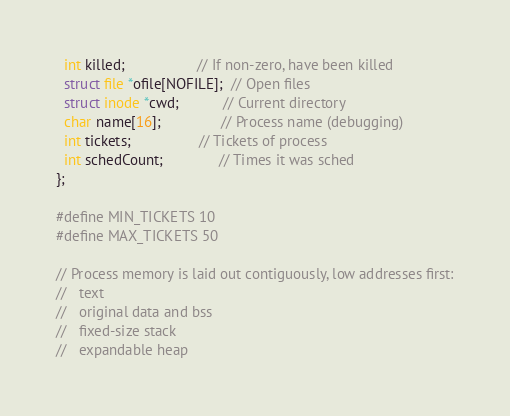<code> <loc_0><loc_0><loc_500><loc_500><_C_>  int killed;                  // If non-zero, have been killed
  struct file *ofile[NOFILE];  // Open files
  struct inode *cwd;           // Current directory
  char name[16];               // Process name (debugging)
  int tickets;                 // Tickets of process
  int schedCount;              // Times it was sched
};

#define MIN_TICKETS 10
#define MAX_TICKETS 50

// Process memory is laid out contiguously, low addresses first:
//   text
//   original data and bss
//   fixed-size stack
//   expandable heap
</code> 